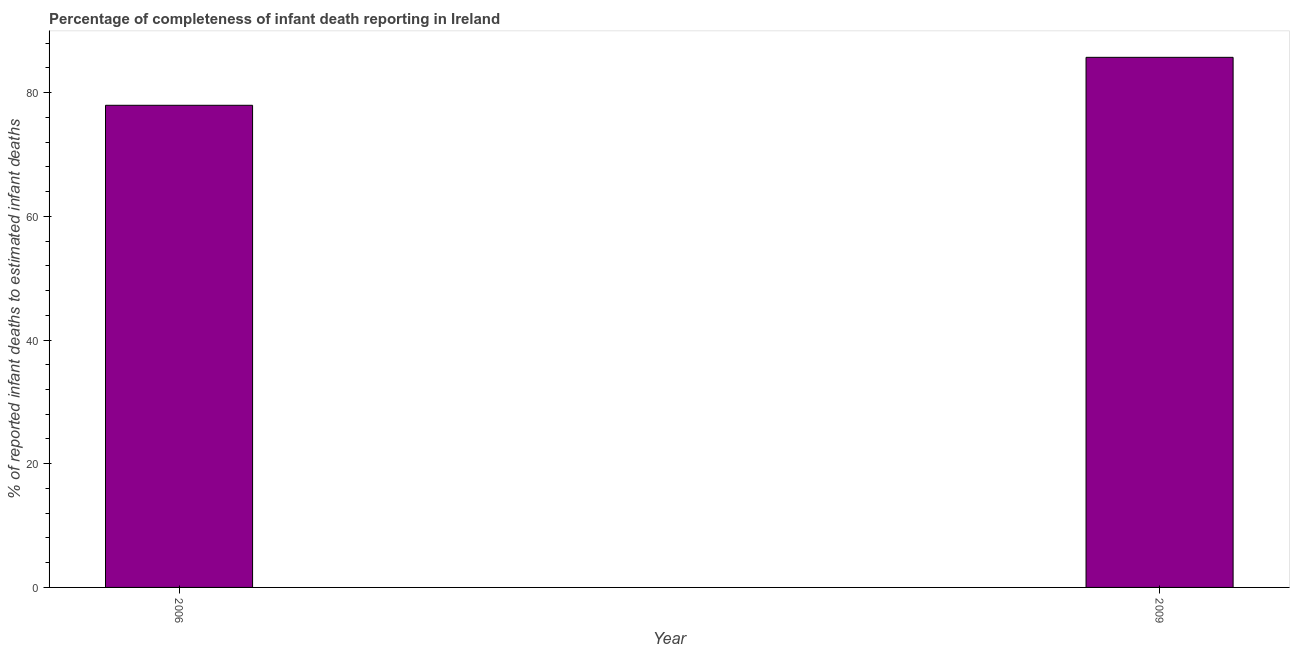What is the title of the graph?
Make the answer very short. Percentage of completeness of infant death reporting in Ireland. What is the label or title of the Y-axis?
Ensure brevity in your answer.  % of reported infant deaths to estimated infant deaths. What is the completeness of infant death reporting in 2009?
Provide a succinct answer. 85.71. Across all years, what is the maximum completeness of infant death reporting?
Your response must be concise. 85.71. Across all years, what is the minimum completeness of infant death reporting?
Offer a terse response. 77.96. In which year was the completeness of infant death reporting maximum?
Make the answer very short. 2009. In which year was the completeness of infant death reporting minimum?
Your answer should be very brief. 2006. What is the sum of the completeness of infant death reporting?
Provide a succinct answer. 163.67. What is the difference between the completeness of infant death reporting in 2006 and 2009?
Provide a succinct answer. -7.75. What is the average completeness of infant death reporting per year?
Ensure brevity in your answer.  81.84. What is the median completeness of infant death reporting?
Make the answer very short. 81.84. In how many years, is the completeness of infant death reporting greater than 60 %?
Give a very brief answer. 2. What is the ratio of the completeness of infant death reporting in 2006 to that in 2009?
Provide a short and direct response. 0.91. In how many years, is the completeness of infant death reporting greater than the average completeness of infant death reporting taken over all years?
Your answer should be very brief. 1. Are all the bars in the graph horizontal?
Ensure brevity in your answer.  No. What is the difference between two consecutive major ticks on the Y-axis?
Give a very brief answer. 20. What is the % of reported infant deaths to estimated infant deaths of 2006?
Give a very brief answer. 77.96. What is the % of reported infant deaths to estimated infant deaths of 2009?
Give a very brief answer. 85.71. What is the difference between the % of reported infant deaths to estimated infant deaths in 2006 and 2009?
Provide a succinct answer. -7.75. What is the ratio of the % of reported infant deaths to estimated infant deaths in 2006 to that in 2009?
Keep it short and to the point. 0.91. 